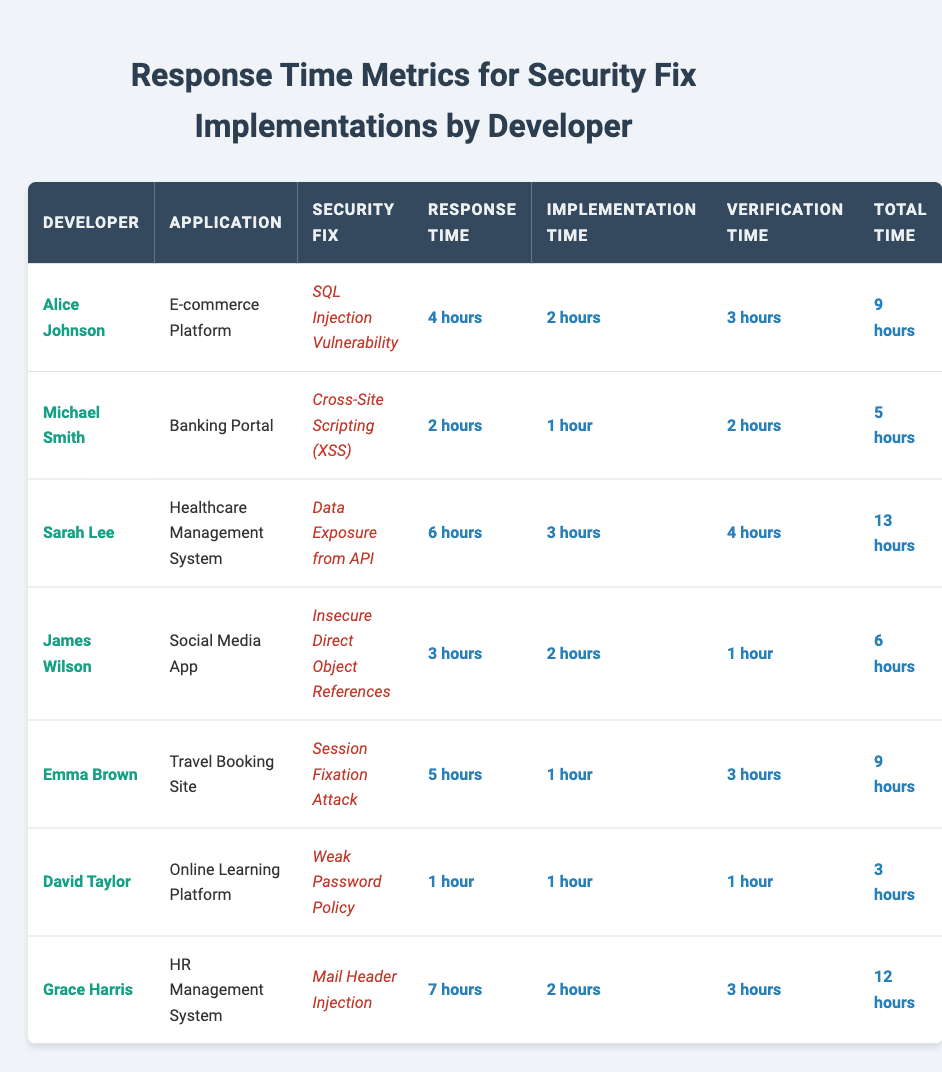What is the total time taken by Sarah Lee to implement the security fix? Sarah Lee's total time is directly stated in the table as "13 hours."
Answer: 13 hours Who took the least time to implement a security fix? David Taylor took "1 hour" for implementation, which is the least compared to all other developers.
Answer: David Taylor What is the average response time for all developers? The total response time is calculated by adding all individual response times (4 + 2 + 6 + 3 + 5 + 1 + 7 = 28 hours) and dividing by the number of developers (7). The average is 28 / 7 = 4 hours.
Answer: 4 hours Did Emma Brown’s total time exceed 10 hours? Emma Brown's total time is "9 hours," which does not exceed 10 hours.
Answer: No Who had the highest verification time, and what was it? Grace Harris had the highest verification time of "3 hours," as indicated in the verification time column for each developer.
Answer: Grace Harris, 3 hours What is the difference between the total time of Alice Johnson and Michael Smith? Alice Johnson's total time is "9 hours," and Michael Smith's total time is "5 hours." The difference is 9 - 5 = 4 hours.
Answer: 4 hours Which developer spent the longest on both implementation and verification time combined? Sarah Lee had an implementation time of "3 hours" and a verification time of "4 hours," totaling 7 hours, which is more than any other developer's combined times.
Answer: Sarah Lee Is there a developer who had a response time of more than 5 hours? Sarah Lee (6 hours) and Grace Harris (7 hours) both had response times greater than 5 hours.
Answer: Yes What is the total time taken by all developers combined? The total time can be calculated by adding all total times (9 + 5 + 13 + 6 + 9 + 3 + 12 = 57 hours).
Answer: 57 hours What security fix did Michael Smith implement? The table shows that Michael Smith implemented the "Cross-Site Scripting (XSS)" security fix.
Answer: Cross-Site Scripting (XSS) 